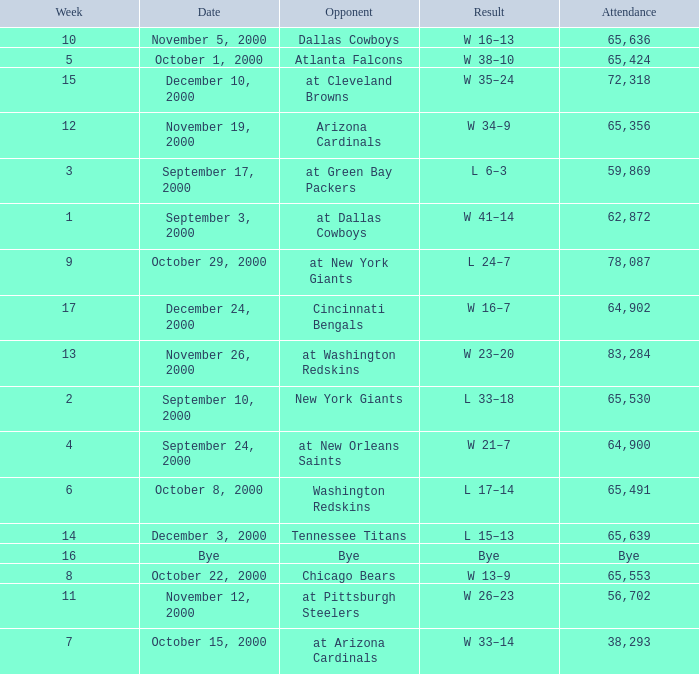What was the attendance when the Cincinnati Bengals were the opponents? 64902.0. Could you parse the entire table? {'header': ['Week', 'Date', 'Opponent', 'Result', 'Attendance'], 'rows': [['10', 'November 5, 2000', 'Dallas Cowboys', 'W 16–13', '65,636'], ['5', 'October 1, 2000', 'Atlanta Falcons', 'W 38–10', '65,424'], ['15', 'December 10, 2000', 'at Cleveland Browns', 'W 35–24', '72,318'], ['12', 'November 19, 2000', 'Arizona Cardinals', 'W 34–9', '65,356'], ['3', 'September 17, 2000', 'at Green Bay Packers', 'L 6–3', '59,869'], ['1', 'September 3, 2000', 'at Dallas Cowboys', 'W 41–14', '62,872'], ['9', 'October 29, 2000', 'at New York Giants', 'L 24–7', '78,087'], ['17', 'December 24, 2000', 'Cincinnati Bengals', 'W 16–7', '64,902'], ['13', 'November 26, 2000', 'at Washington Redskins', 'W 23–20', '83,284'], ['2', 'September 10, 2000', 'New York Giants', 'L 33–18', '65,530'], ['4', 'September 24, 2000', 'at New Orleans Saints', 'W 21–7', '64,900'], ['6', 'October 8, 2000', 'Washington Redskins', 'L 17–14', '65,491'], ['14', 'December 3, 2000', 'Tennessee Titans', 'L 15–13', '65,639'], ['16', 'Bye', 'Bye', 'Bye', 'Bye'], ['8', 'October 22, 2000', 'Chicago Bears', 'W 13–9', '65,553'], ['11', 'November 12, 2000', 'at Pittsburgh Steelers', 'W 26–23', '56,702'], ['7', 'October 15, 2000', 'at Arizona Cardinals', 'W 33–14', '38,293']]} 